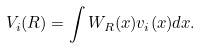<formula> <loc_0><loc_0><loc_500><loc_500>V _ { i } ( R ) = \int W _ { R } ( { x } ) v _ { i } ( { x } ) d { x } .</formula> 